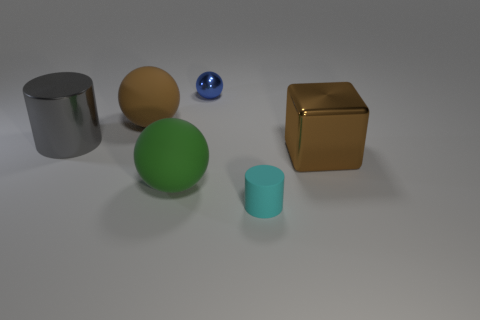Subtract all large balls. How many balls are left? 1 Subtract all green balls. How many balls are left? 2 Subtract all cubes. How many objects are left? 5 Subtract all red cylinders. Subtract all brown cubes. How many cylinders are left? 2 Subtract all red cylinders. How many brown spheres are left? 1 Subtract all tiny cyan things. Subtract all small blue metallic things. How many objects are left? 4 Add 1 rubber balls. How many rubber balls are left? 3 Add 3 green spheres. How many green spheres exist? 4 Add 4 big cyan rubber balls. How many objects exist? 10 Subtract 0 cyan spheres. How many objects are left? 6 